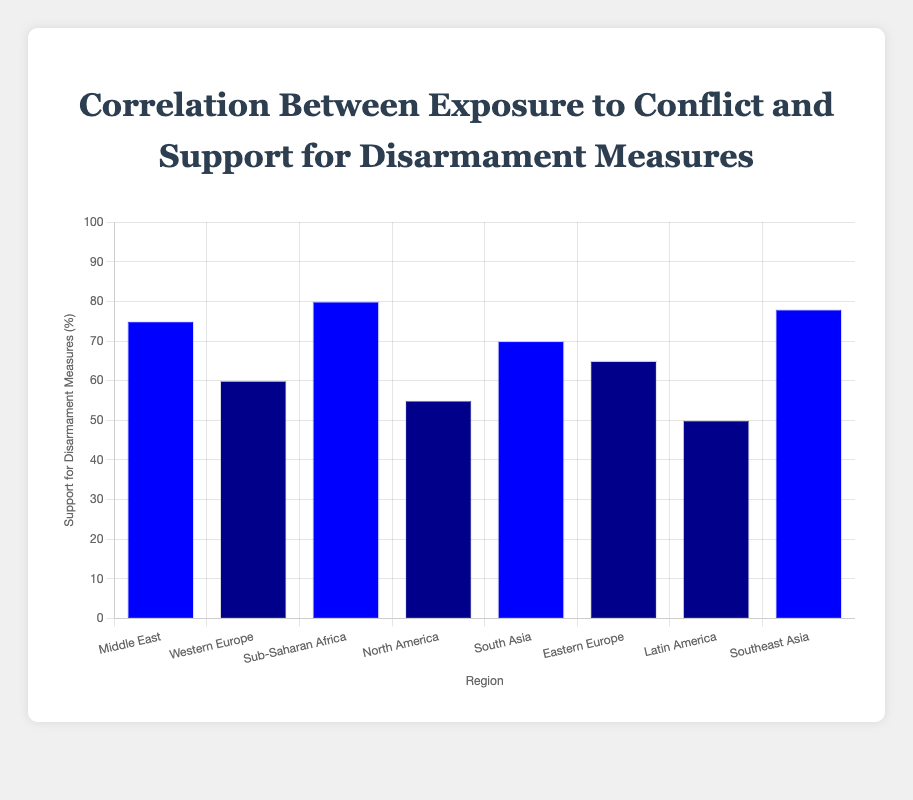Which region has the highest support for disarmament measures? The bar chart indicates that the Sub-Saharan Africa region, with high conflict exposure, has the highest support for disarmament measures at 80%.
Answer: Sub-Saharan Africa Compare the support for disarmament measures between regions with high conflict exposure. The regions with high conflict exposure are the Middle East (75%), Sub-Saharan Africa (80%), and Southeast Asia (78%). Sub-Saharan Africa (80%) shows the highest support, followed closely by Southeast Asia (78%), and then the Middle East (75%).
Answer: Sub-Saharan Africa > Southeast Asia > Middle East What is the difference in support for disarmament measures between North America and South Asia? North America has a support level of 55% while South Asia shows a support level of 70%. The difference is calculated as 70% - 55% = 15%.
Answer: 15% Identify the regions with low conflict exposure and compare their support for disarmament measures. The regions with low conflict exposure are Western Europe (60%), North America (55%), and Latin America (50%). Western Europe has the highest support at 60%, followed by North America at 55%, and then Latin America at 50%.
Answer: Western Europe > North America > Latin America Calculate the average support for disarmament measures across all regions in the chart. To find the average, sum up all support percentages and divide by the number of regions: (75 + 60 + 80 + 55 + 70 + 65 + 50 + 78) / 8 = 533 / 8 = 66.625.
Answer: 66.625 What color represents the regions with medium conflict exposure? According to the bar chart, the regions with medium conflict exposure, South Asia and Eastern Europe, are represented with two different colors: blue and dark blue respectively.
Answer: Blue, Dark Blue Which region with medium conflict exposure has a higher support for disarmament measures? The regions with medium conflict exposure are South Asia with 70% and Eastern Europe with 65%. South Asia has higher support.
Answer: South Asia List the regions in descending order based on their support for disarmament measures. The regions listed from highest to lowest support for disarmament measures are Sub-Saharan Africa (80%), Southeast Asia (78%), Middle East (75%), South Asia (70%), Eastern Europe (65%), Western Europe (60%), North America (55%), and Latin America (50%).
Answer: Sub-Saharan Africa > Southeast Asia > Middle East > South Asia > Eastern Europe > Western Europe > North America > Latin America What is the combined support percentage for disarmament measures in regions with high conflict exposure? The regions with high conflict exposure are Middle East (75%), Sub-Saharan Africa (80%), and Southeast Asia (78%). The combined support percentage is 75 + 80 + 78 = 233%.
Answer: 233% Compare the support for disarmament measures between Western Europe and the Middle East. Western Europe, with low conflict exposure, has a support level of 60%, while the Middle East, with high conflict exposure, has a support level of 75%. The Middle East shows higher support for disarmament measures by 15% compared to Western Europe.
Answer: Middle East > Western Europe by 15% 